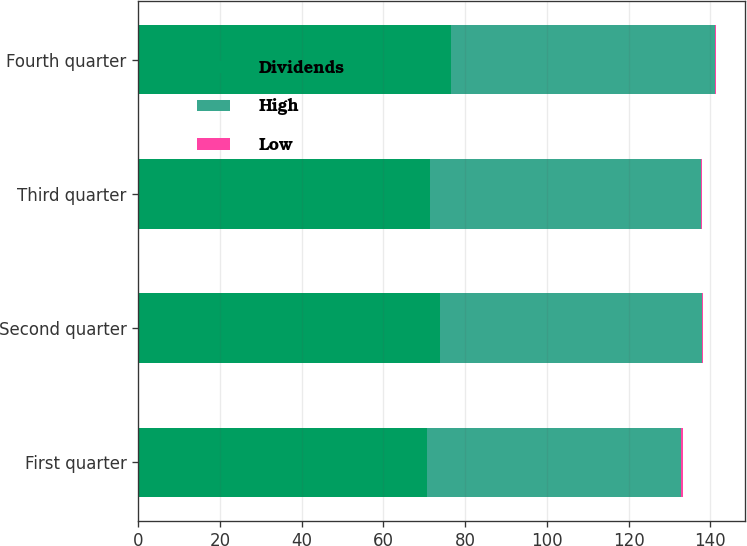Convert chart. <chart><loc_0><loc_0><loc_500><loc_500><stacked_bar_chart><ecel><fcel>First quarter<fcel>Second quarter<fcel>Third quarter<fcel>Fourth quarter<nl><fcel>Dividends<fcel>70.55<fcel>73.86<fcel>71.45<fcel>76.45<nl><fcel>High<fcel>62.35<fcel>63.98<fcel>66.21<fcel>64.59<nl><fcel>Low<fcel>0.32<fcel>0.32<fcel>0.32<fcel>0.32<nl></chart> 